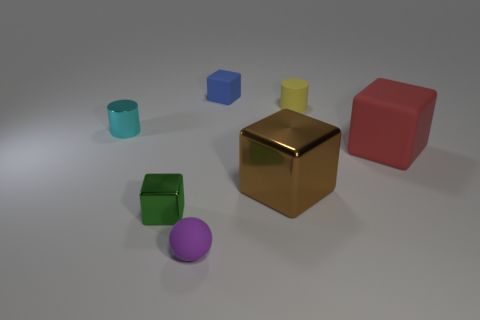Is the material of the tiny yellow object behind the small shiny block the same as the small block in front of the shiny cylinder?
Your answer should be very brief. No. What color is the matte sphere that is the same size as the cyan cylinder?
Provide a succinct answer. Purple. Are there any other things that are the same color as the tiny rubber cube?
Keep it short and to the point. No. How big is the block on the left side of the rubber block to the left of the big object that is on the right side of the yellow rubber object?
Offer a terse response. Small. There is a cube that is behind the big brown shiny object and to the left of the big brown thing; what color is it?
Your response must be concise. Blue. There is a thing in front of the tiny green block; what size is it?
Your response must be concise. Small. How many yellow cylinders are the same material as the cyan cylinder?
Ensure brevity in your answer.  0. There is a tiny metal thing in front of the large red block; is it the same shape as the big brown object?
Offer a terse response. Yes. There is a small ball that is the same material as the big red object; what is its color?
Keep it short and to the point. Purple. There is a tiny cylinder behind the cylinder that is on the left side of the green cube; are there any red matte things behind it?
Offer a very short reply. No. 